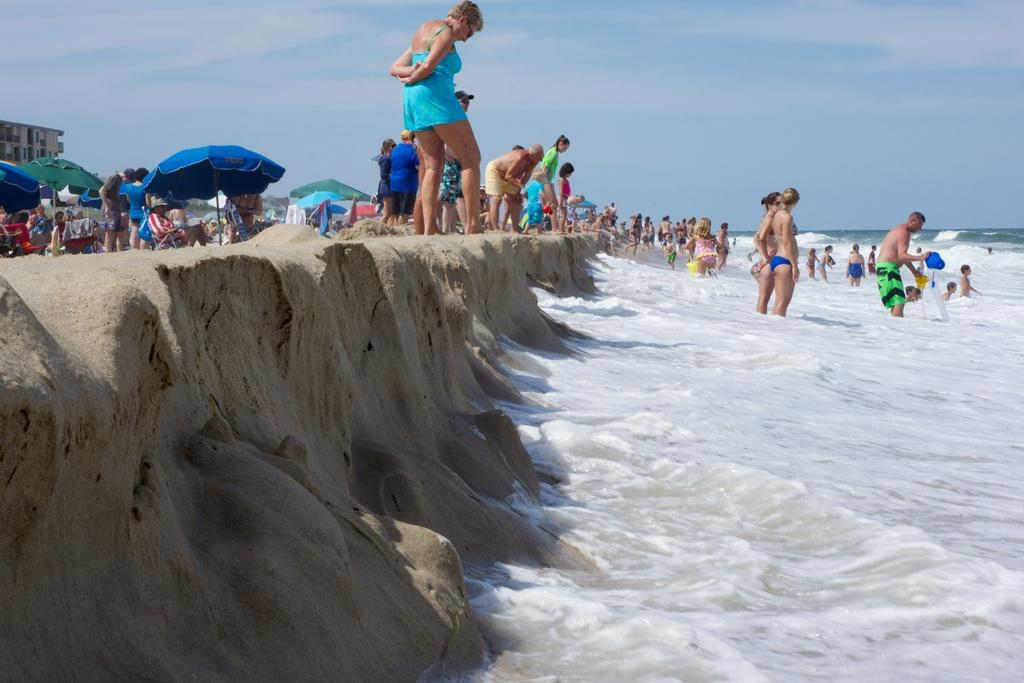What are the people in the image doing? There are people standing in the water and on the seashore in the image. What structures can be seen in the image? There are tents and a building in the image. How would you describe the sky in the image? The sky is blue and cloudy in the image. What type of reaction can be seen from the moon in the image? There is no moon present in the image, so it is not possible to observe any reaction from it. 